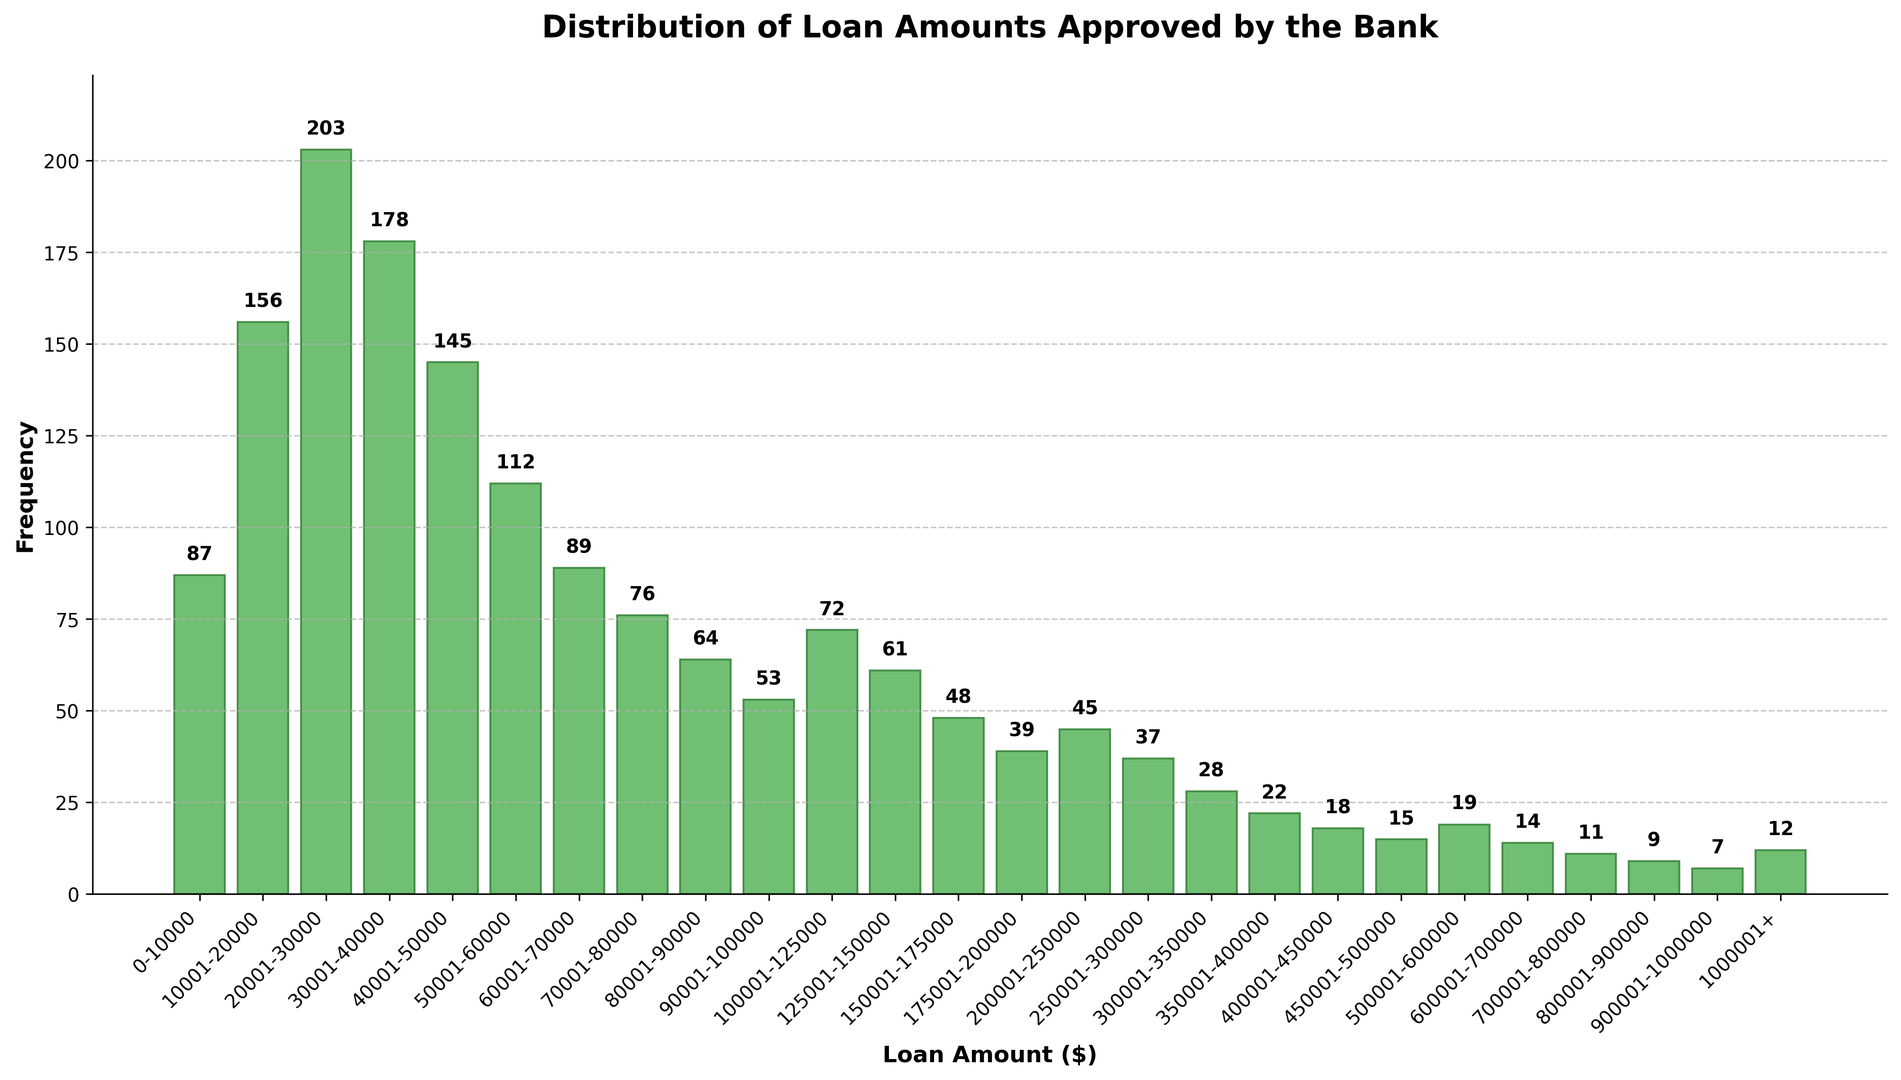What's the most common loan amount range approved? By looking at the heights of the bars in the histogram, the tallest bar corresponds to the most common loan amount range. The $20,001-$30,000 range has the highest frequency.
Answer: $20,001-$30,000 Which range has the least number of loans approved, and how many loans were approved in that range? By identifying the shortest bar on the histogram, we can determine the range with the least number of loans approved. The range $900,001-$1,000,000 has the fewest approvals, with a frequency of 7.
Answer: $900,001-$1,000,000 and 7 Compare the loan frequencies for the ranges $300,001-$350,000 and $350,001-$400,000. Which one is higher? From the histogram, compare the heights of the two bars for these ranges. The $300,001-$350,000 range has a frequency of 28, while the $350,001-$400,000 range has a frequency of 22. Thus, the $300,001-$350,000 range is higher.
Answer: $300,001-$350,000 What is the total number of loans approved in the range $0-$100,000? Add the frequencies for all ranges within $0-$100,000: 87 (for $0-$10,000) + 156 (for $10,001-$20,000) + 203 (for $20,001-$30,000) + 178 (for $30,001-$40,000) + 145 (for $40,001-$50,000) + 112 (for $50,001-$60,000) + 89 (for $60,001-$70,000) + 76 (for $70,001-$80,000) + 64 (for $80,001-$90,000) + 53 (for $90,001-$100,000). The sum is 1163.
Answer: 1163 What is the average frequency of loans approved for the ranges $0-$100,000? Add the frequencies for all the ranges within $0-$100,000 as done above, which gives 1163. Then divide by the number of ranges, which is 10. So, 1163 / 10 = 116.3.
Answer: 116.3 Which loan amount range has nearly half the frequency of the $30,001-$40,000 range? The frequency for the $30,001-$40,000 range is 178. Half of 178 is 89. Checking the frequencies, the $60,001-$70,000 range has a frequency of 89, which is nearly half of 178.
Answer: $60,001-$70,000 What can be said about the distribution of loan amounts over the provided ranges? The histogram shows a right-skewed distribution where most loan amounts are approved in lower ranges, with frequencies gradually decreasing as the loan amount increases. The highest frequency is seen in the $20,001-$30,000 range, and frequencies decrease substantially beyond $100,000.
Answer: Right-skewed distribution with most approvals in lower ranges How does the frequency of loans approved in the $150,001-$175,000 range compare to those in the $450,001-$500,000 range? The frequency for $150,001-$175,000 is 48, while for the $450,001-$500,000 range it is 15. Thus, the $150,001-$175,000 range has a significantly higher frequency compared to the $450,001-$500,000 range.
Answer: $150,001-$175,000 has a higher frequency What is the approximate ratio of loans approved in the $20,001-$30,000 range compared to the $40,001-$50,000 range? The frequency for the $20,001-$30,000 range is 203, and for the $40,001-$50,000 range it is 145. The ratio is approximately 203:145. Simplifying this gives roughly 1.4:1.
Answer: 1.4:1 